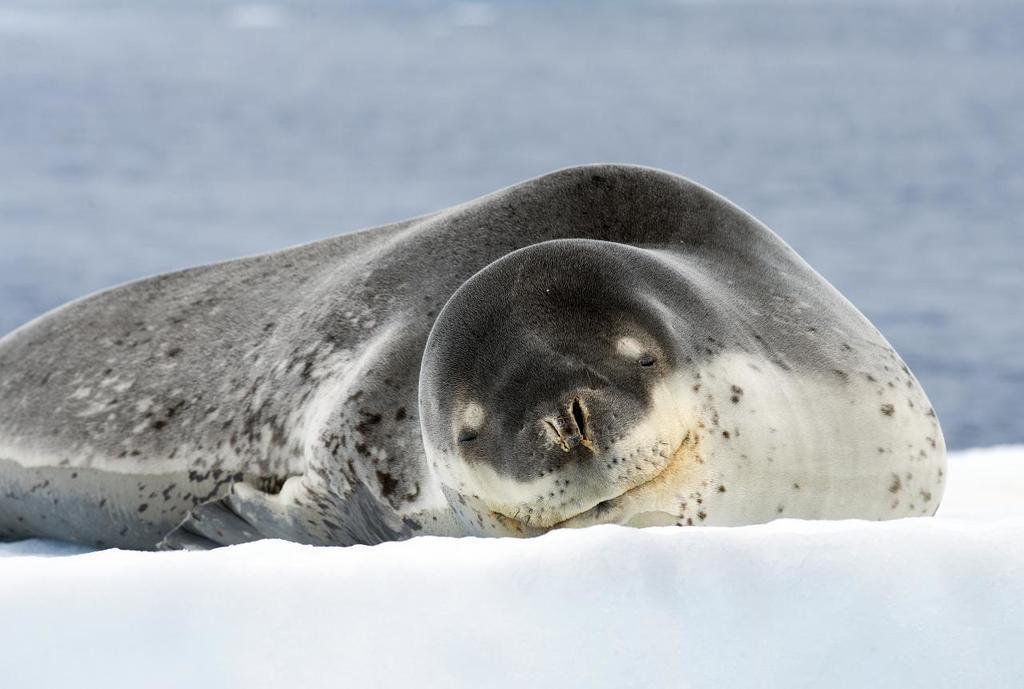Describe this image in one or two sentences. Here, we can see a black color seal and there is white color snow, in the background we can see water. 